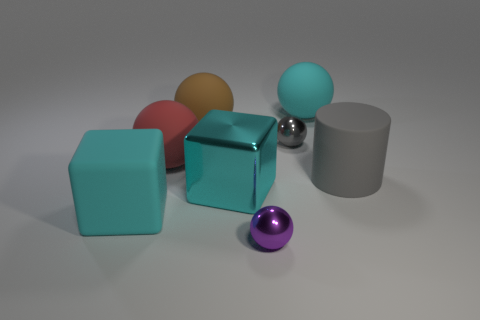Subtract all cyan spheres. How many spheres are left? 4 Subtract all cyan rubber spheres. How many spheres are left? 4 Subtract all blue spheres. Subtract all red cylinders. How many spheres are left? 5 Add 1 large matte things. How many objects exist? 9 Subtract all balls. How many objects are left? 3 Add 4 large brown rubber spheres. How many large brown rubber spheres exist? 5 Subtract 0 purple blocks. How many objects are left? 8 Subtract all small red blocks. Subtract all rubber spheres. How many objects are left? 5 Add 4 big metal things. How many big metal things are left? 5 